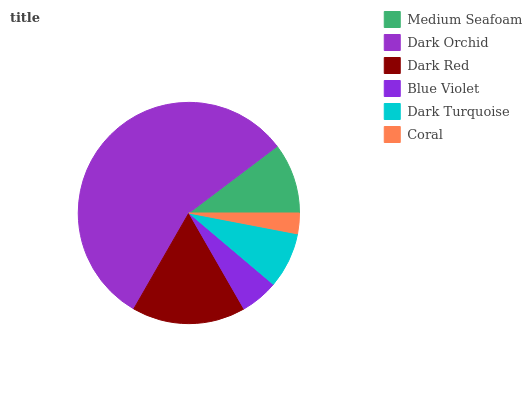Is Coral the minimum?
Answer yes or no. Yes. Is Dark Orchid the maximum?
Answer yes or no. Yes. Is Dark Red the minimum?
Answer yes or no. No. Is Dark Red the maximum?
Answer yes or no. No. Is Dark Orchid greater than Dark Red?
Answer yes or no. Yes. Is Dark Red less than Dark Orchid?
Answer yes or no. Yes. Is Dark Red greater than Dark Orchid?
Answer yes or no. No. Is Dark Orchid less than Dark Red?
Answer yes or no. No. Is Medium Seafoam the high median?
Answer yes or no. Yes. Is Dark Turquoise the low median?
Answer yes or no. Yes. Is Blue Violet the high median?
Answer yes or no. No. Is Dark Red the low median?
Answer yes or no. No. 